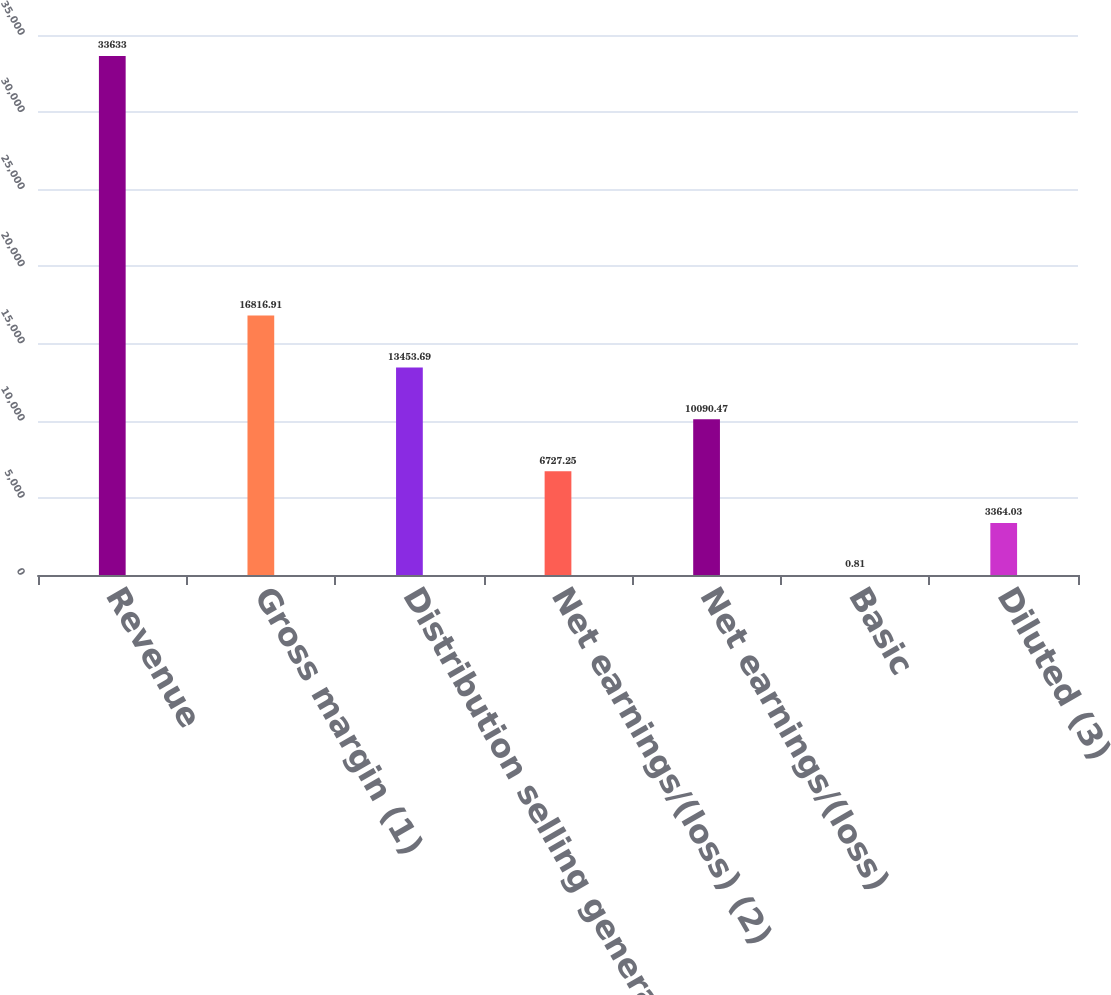Convert chart. <chart><loc_0><loc_0><loc_500><loc_500><bar_chart><fcel>Revenue<fcel>Gross margin (1)<fcel>Distribution selling general<fcel>Net earnings/(loss) (2)<fcel>Net earnings/(loss)<fcel>Basic<fcel>Diluted (3)<nl><fcel>33633<fcel>16816.9<fcel>13453.7<fcel>6727.25<fcel>10090.5<fcel>0.81<fcel>3364.03<nl></chart> 